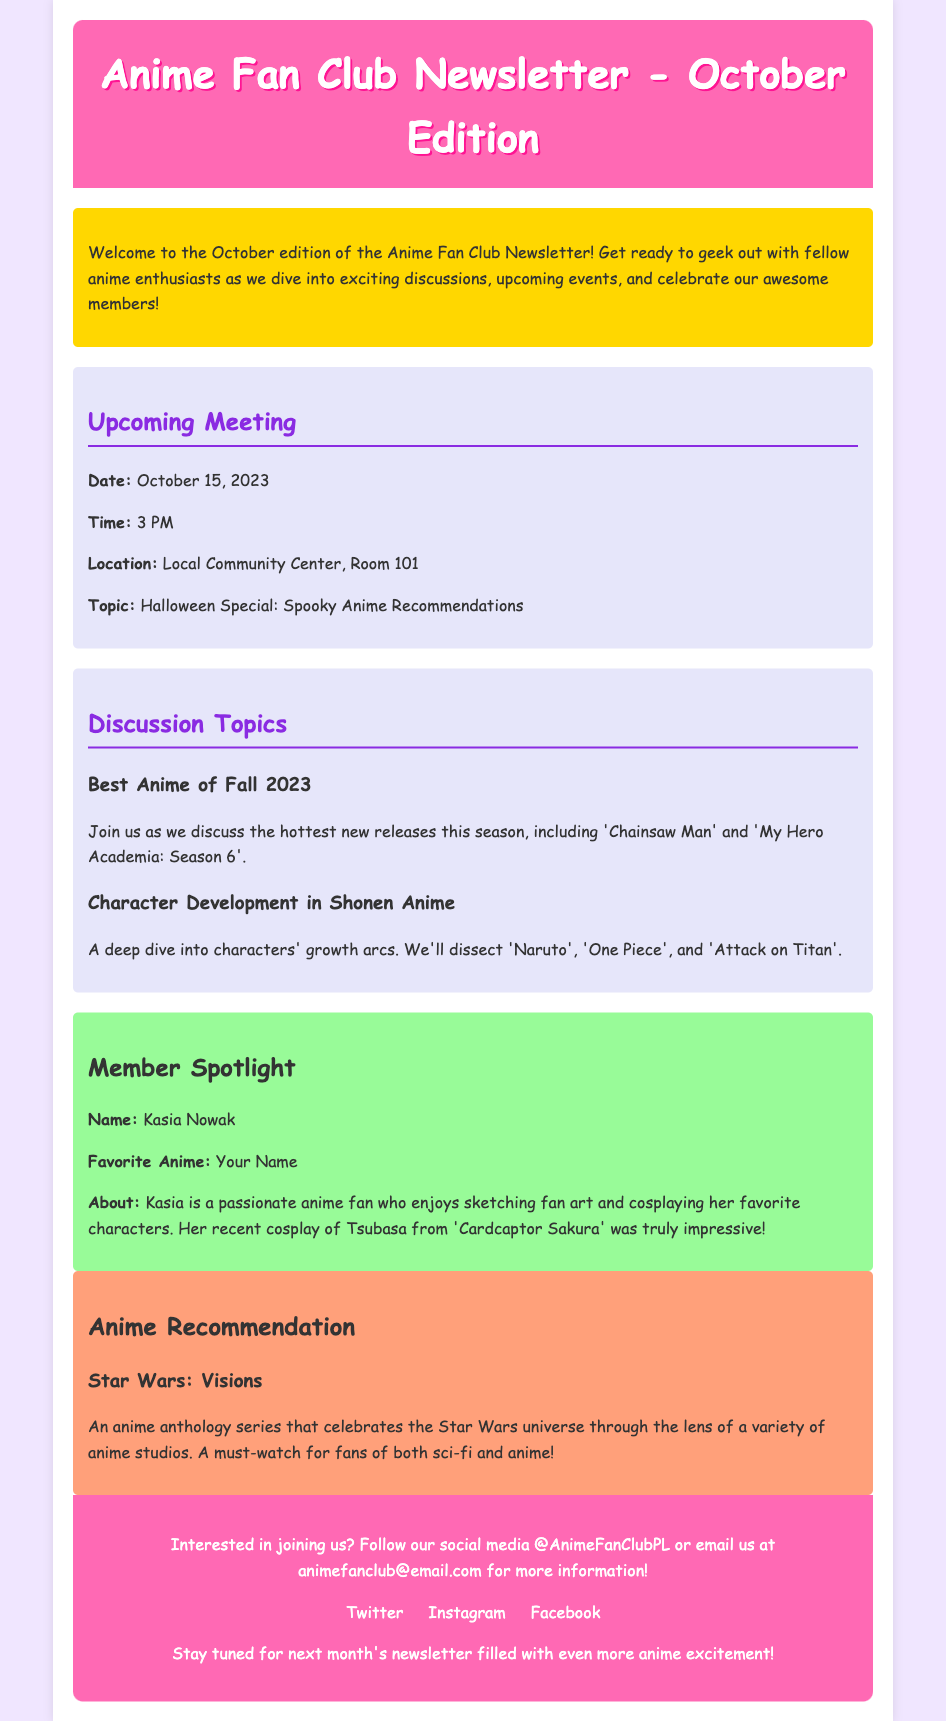What is the date of the upcoming meeting? The upcoming meeting is scheduled for October 15, 2023.
Answer: October 15, 2023 What is the meeting topic? The topic for the meeting is Halloween Special: Spooky Anime Recommendations.
Answer: Halloween Special: Spooky Anime Recommendations Who is the member spotlighted in this edition? The member spotlighted is Kasia Nowak.
Answer: Kasia Nowak What is the favorite anime of the member spotlighted? The favorite anime of Kasia Nowak is Your Name.
Answer: Your Name What is one discussion topic mentioned? One discussion topic is Best Anime of Fall 2023.
Answer: Best Anime of Fall 2023 What anime is recommended in this newsletter? The recommended anime is Star Wars: Visions.
Answer: Star Wars: Visions What is the time for the upcoming meeting? The time for the upcoming meeting is 3 PM.
Answer: 3 PM What is the location of the upcoming meeting? The location for the upcoming meeting is Local Community Center, Room 101.
Answer: Local Community Center, Room 101 What is the color of the footer background? The footer background color is pink.
Answer: pink 